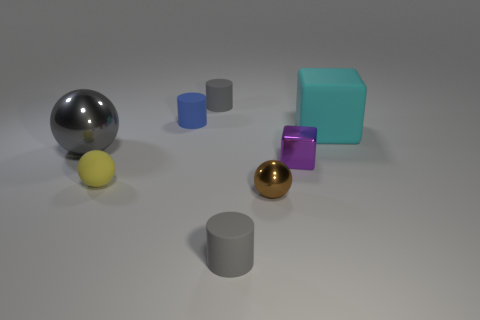What number of other objects are there of the same material as the gray sphere?
Ensure brevity in your answer.  2. What number of rubber objects are tiny things or cyan objects?
Offer a terse response. 5. There is a big metal object that is the same shape as the tiny yellow rubber thing; what is its color?
Provide a short and direct response. Gray. What number of objects are either big metal objects or big cubes?
Make the answer very short. 2. The cyan thing that is the same material as the small yellow sphere is what shape?
Your answer should be compact. Cube. How many small objects are green matte blocks or purple blocks?
Make the answer very short. 1. How many other things are the same color as the large ball?
Provide a succinct answer. 2. There is a gray matte cylinder that is behind the shiny object that is left of the small brown metallic sphere; what number of tiny gray rubber cylinders are on the right side of it?
Ensure brevity in your answer.  1. There is a block that is behind the metal cube; is it the same size as the gray metallic sphere?
Ensure brevity in your answer.  Yes. Are there fewer small rubber balls that are to the left of the big sphere than metallic objects that are behind the blue rubber object?
Your response must be concise. No. 